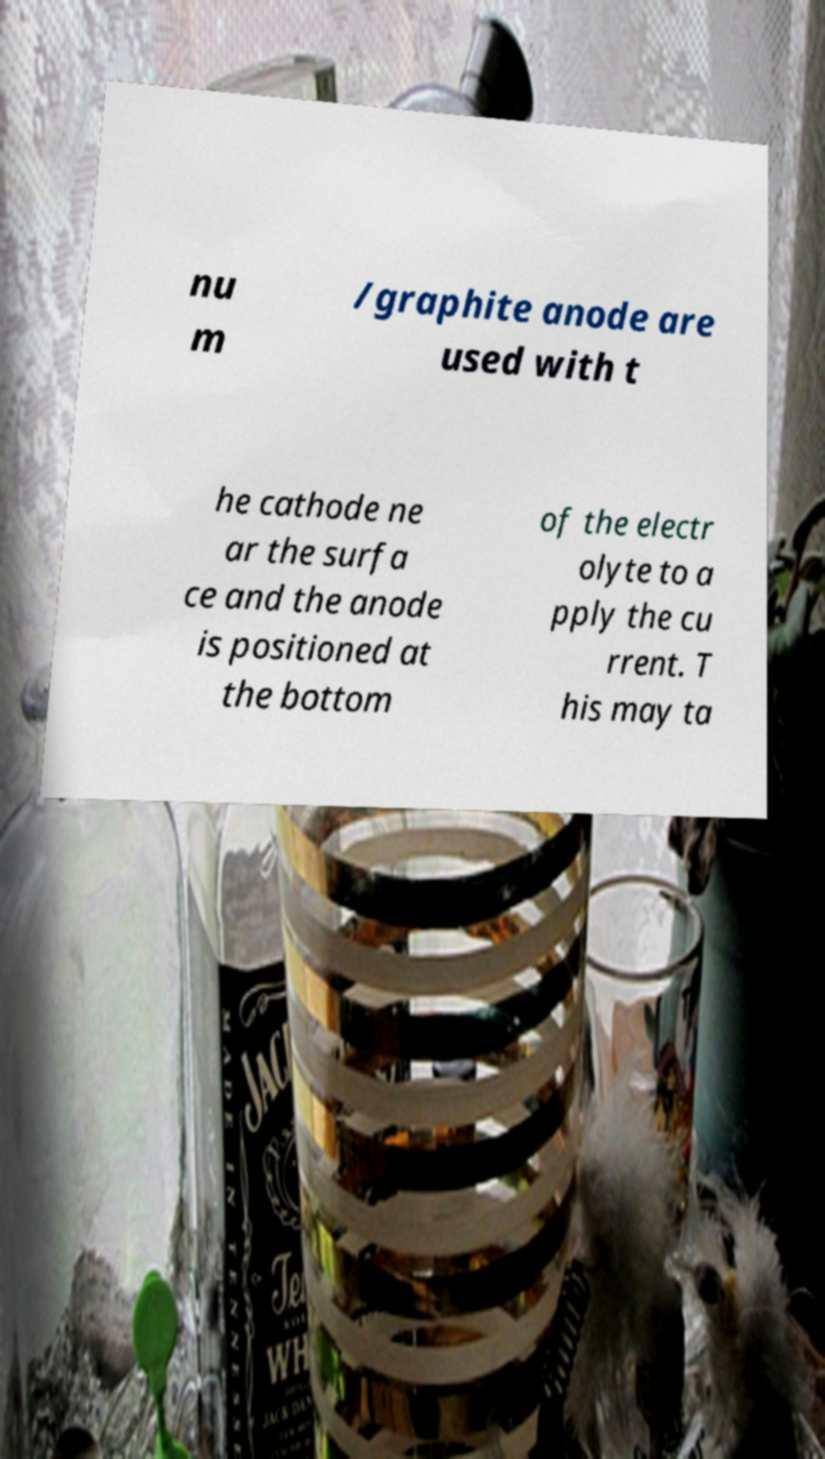Can you accurately transcribe the text from the provided image for me? nu m /graphite anode are used with t he cathode ne ar the surfa ce and the anode is positioned at the bottom of the electr olyte to a pply the cu rrent. T his may ta 